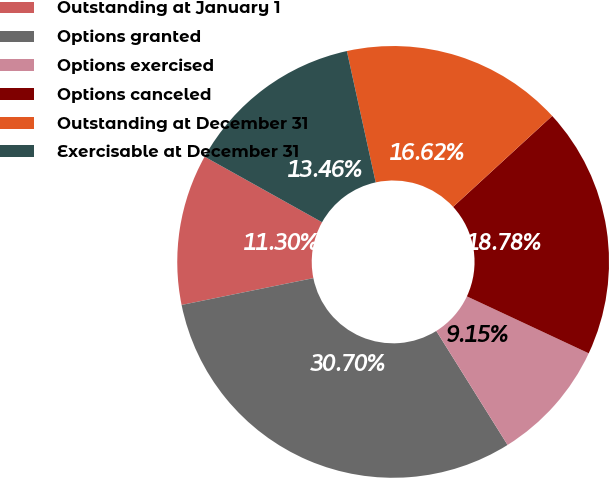<chart> <loc_0><loc_0><loc_500><loc_500><pie_chart><fcel>Outstanding at January 1<fcel>Options granted<fcel>Options exercised<fcel>Options canceled<fcel>Outstanding at December 31<fcel>Exercisable at December 31<nl><fcel>11.3%<fcel>30.7%<fcel>9.15%<fcel>18.78%<fcel>16.62%<fcel>13.46%<nl></chart> 